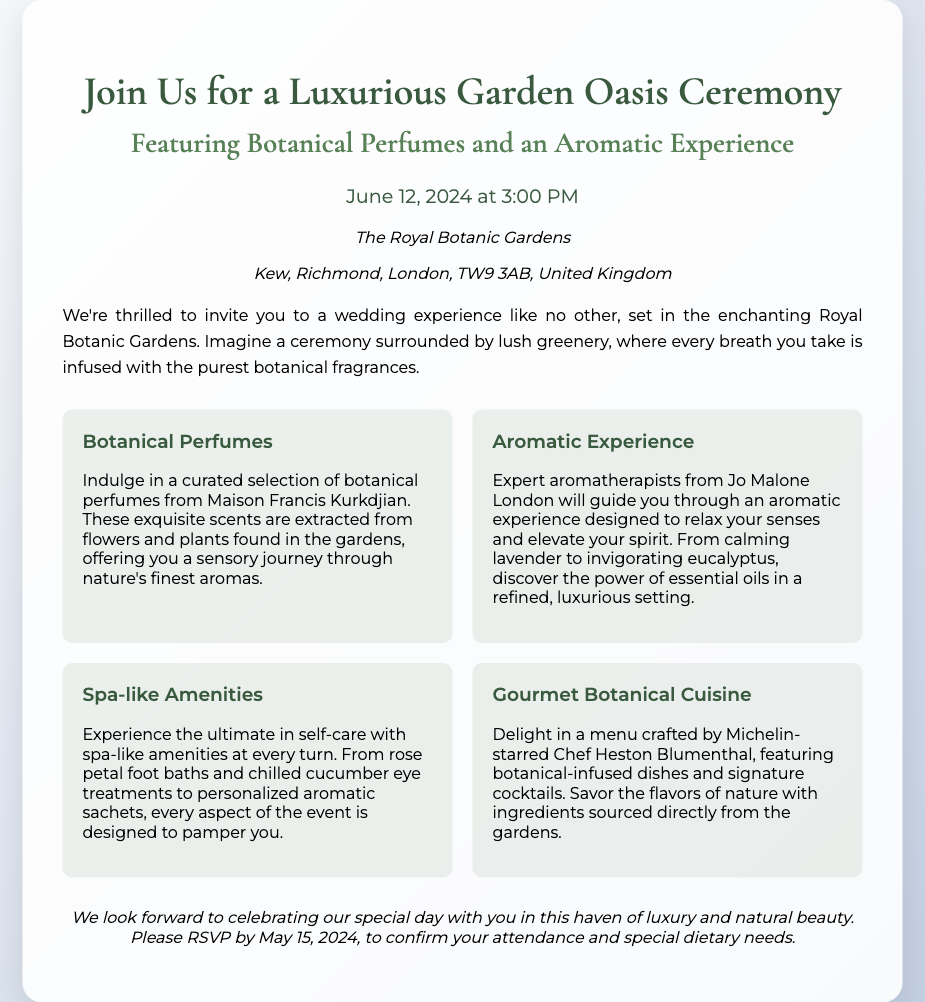What date is the ceremony? The document specifies the date of the ceremony, which is June 12, 2024.
Answer: June 12, 2024 What time does the ceremony start? The time for the ceremony can be found in the date-time section, which indicates it starts at 3:00 PM.
Answer: 3:00 PM Where is the venue located? The venue is listed in the document, named as The Royal Botanic Gardens, Kew, Richmond, London.
Answer: The Royal Botanic Gardens Who is the chef for the event? The document highlights that the menu is crafted by Michelin-starred Chef Heston Blumenthal.
Answer: Heston Blumenthal What type of experience will aromatherapists provide? The document describes the experience to be an aromatic experience designed to relax the senses and elevate the spirit.
Answer: Aromatic experience How should guests confirm their attendance? The invitation specifies that guests should RSVP by May 15, 2024, to confirm attendance and any dietary needs.
Answer: RSVP by May 15, 2024 What amenities will be available for self-care? The document lists spa-like amenities, including rose petal foot baths and chilled cucumber eye treatments.
Answer: Spa-like amenities What type of cuisine will be served at the ceremony? The document mentions that gourmet botanical cuisine will be served, crafted from ingredients sourced from the gardens.
Answer: Gourmet botanical cuisine 